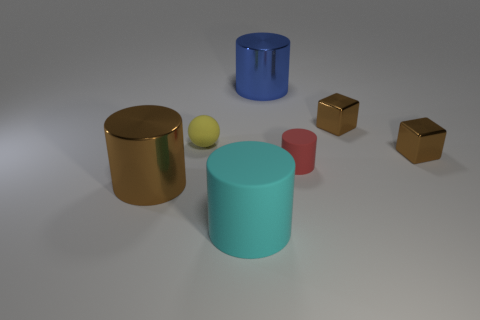Does the tiny brown thing behind the tiny yellow ball have the same material as the large cylinder left of the small yellow matte thing?
Provide a short and direct response. Yes. There is a metal cylinder left of the cyan object; is it the same size as the red rubber cylinder?
Give a very brief answer. No. Do the large rubber object and the rubber cylinder that is behind the big cyan thing have the same color?
Your answer should be compact. No. What is the shape of the red rubber thing?
Provide a short and direct response. Cylinder. Is the color of the tiny sphere the same as the small rubber cylinder?
Keep it short and to the point. No. How many objects are rubber cylinders that are to the left of the big blue shiny thing or rubber objects?
Give a very brief answer. 3. The blue cylinder that is the same material as the brown cylinder is what size?
Keep it short and to the point. Large. Is the number of balls that are in front of the big brown shiny cylinder greater than the number of shiny things?
Offer a very short reply. No. There is a blue object; is it the same shape as the small brown shiny thing that is in front of the small yellow sphere?
Offer a very short reply. No. How many tiny objects are yellow things or brown blocks?
Your answer should be very brief. 3. 